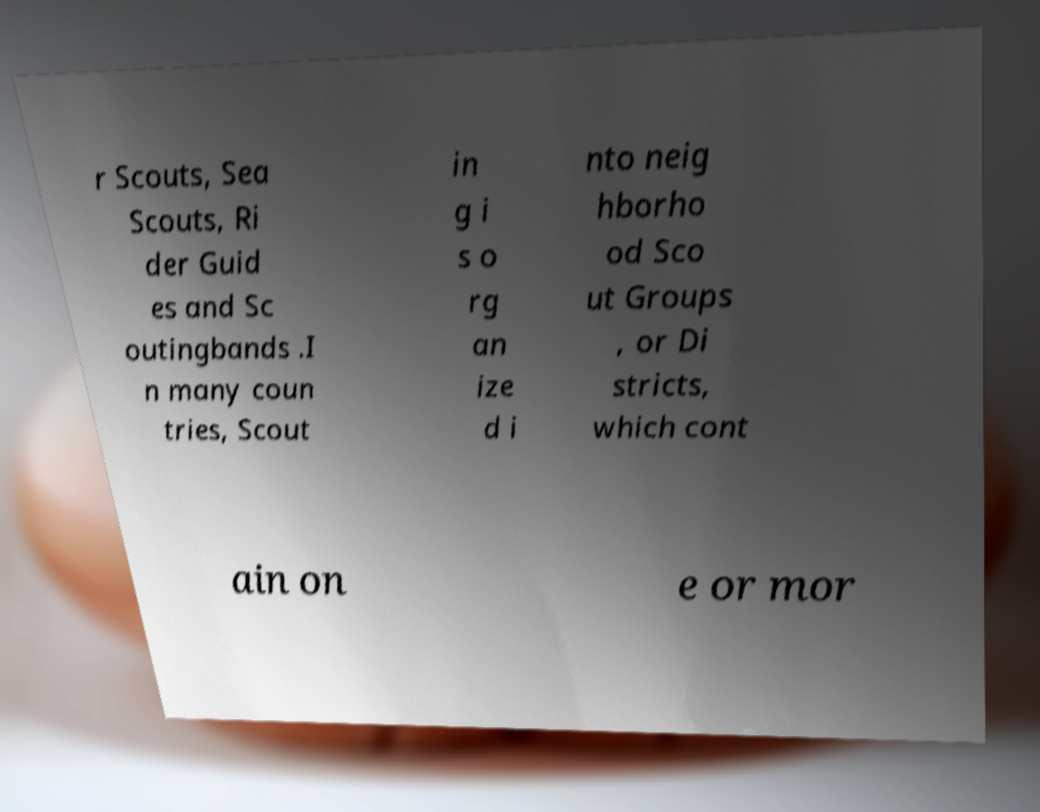I need the written content from this picture converted into text. Can you do that? r Scouts, Sea Scouts, Ri der Guid es and Sc outingbands .I n many coun tries, Scout in g i s o rg an ize d i nto neig hborho od Sco ut Groups , or Di stricts, which cont ain on e or mor 